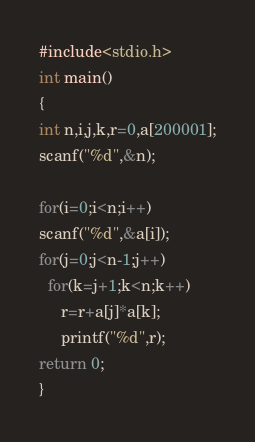Convert code to text. <code><loc_0><loc_0><loc_500><loc_500><_C_>#include<stdio.h>
int main()
{
int n,i,j,k,r=0,a[200001];
scanf("%d",&n);

for(i=0;i<n;i++)
scanf("%d",&a[i]);
for(j=0;j<n-1;j++)
  for(k=j+1;k<n;k++)
     r=r+a[j]*a[k];    
     printf("%d",r);
return 0;
}
</code> 